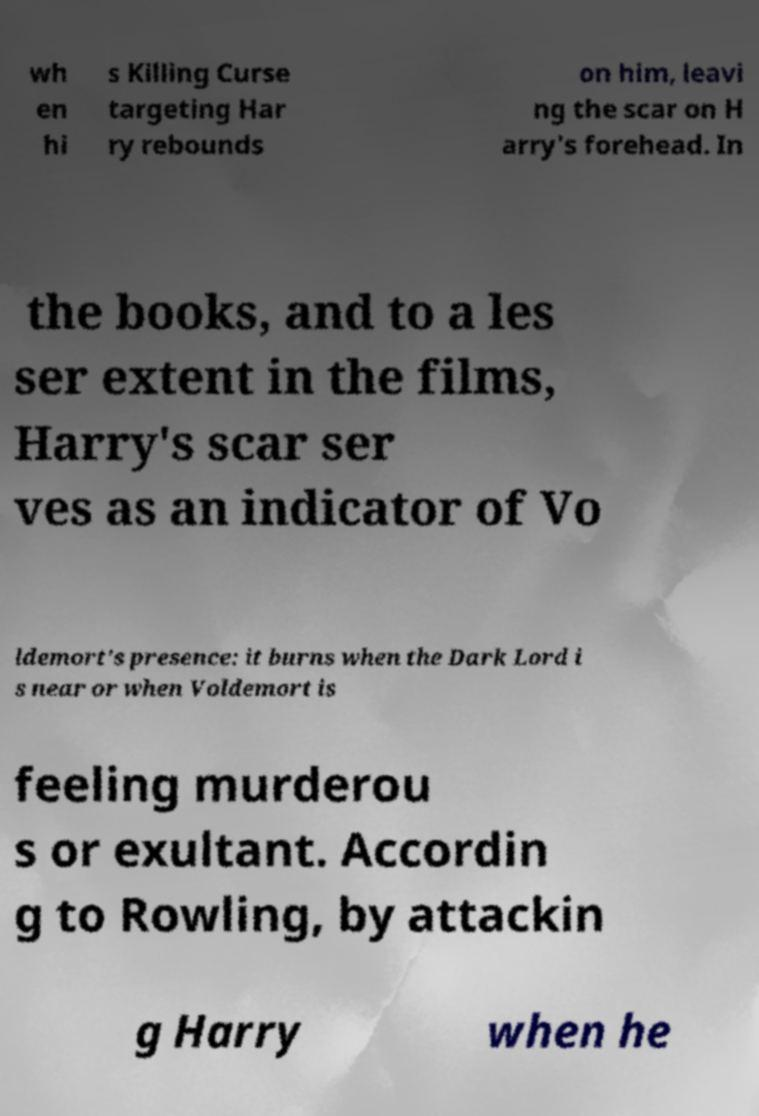Could you assist in decoding the text presented in this image and type it out clearly? wh en hi s Killing Curse targeting Har ry rebounds on him, leavi ng the scar on H arry's forehead. In the books, and to a les ser extent in the films, Harry's scar ser ves as an indicator of Vo ldemort's presence: it burns when the Dark Lord i s near or when Voldemort is feeling murderou s or exultant. Accordin g to Rowling, by attackin g Harry when he 